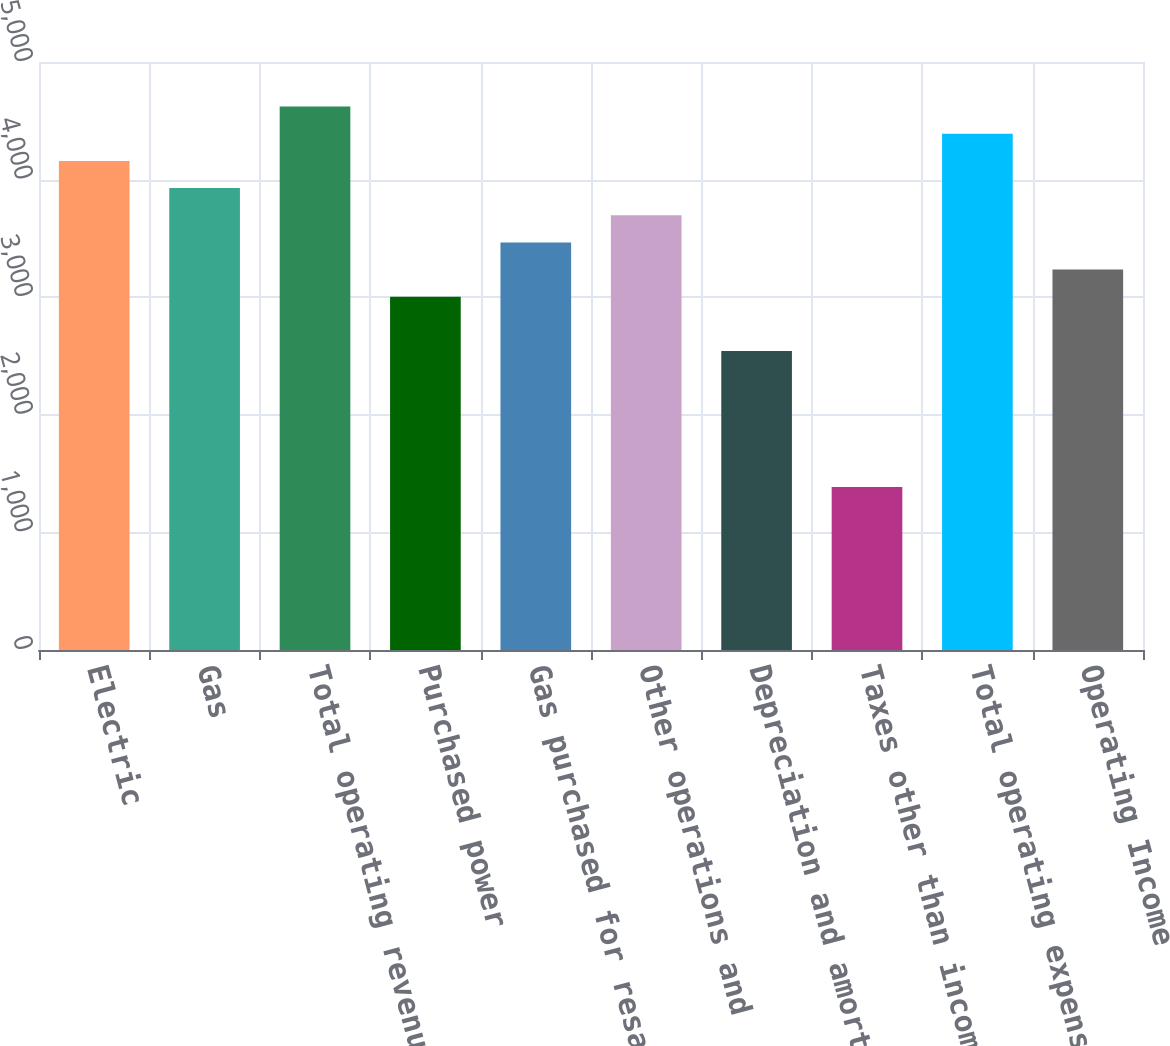Convert chart to OTSL. <chart><loc_0><loc_0><loc_500><loc_500><bar_chart><fcel>Electric<fcel>Gas<fcel>Total operating revenues<fcel>Purchased power<fcel>Gas purchased for resale<fcel>Other operations and<fcel>Depreciation and amortization<fcel>Taxes other than income taxes<fcel>Total operating expenses<fcel>Operating Income<nl><fcel>4159<fcel>3928<fcel>4621<fcel>3004<fcel>3466<fcel>3697<fcel>2542<fcel>1387<fcel>4390<fcel>3235<nl></chart> 